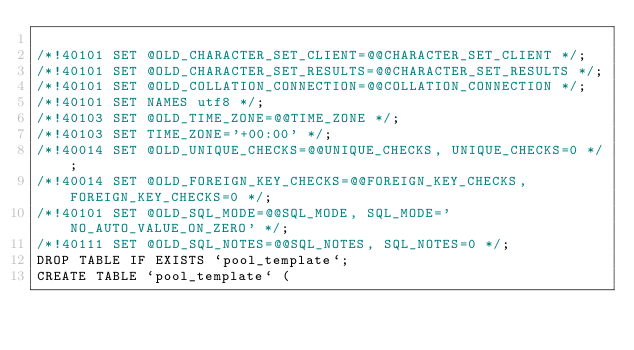<code> <loc_0><loc_0><loc_500><loc_500><_SQL_>
/*!40101 SET @OLD_CHARACTER_SET_CLIENT=@@CHARACTER_SET_CLIENT */;
/*!40101 SET @OLD_CHARACTER_SET_RESULTS=@@CHARACTER_SET_RESULTS */;
/*!40101 SET @OLD_COLLATION_CONNECTION=@@COLLATION_CONNECTION */;
/*!40101 SET NAMES utf8 */;
/*!40103 SET @OLD_TIME_ZONE=@@TIME_ZONE */;
/*!40103 SET TIME_ZONE='+00:00' */;
/*!40014 SET @OLD_UNIQUE_CHECKS=@@UNIQUE_CHECKS, UNIQUE_CHECKS=0 */;
/*!40014 SET @OLD_FOREIGN_KEY_CHECKS=@@FOREIGN_KEY_CHECKS, FOREIGN_KEY_CHECKS=0 */;
/*!40101 SET @OLD_SQL_MODE=@@SQL_MODE, SQL_MODE='NO_AUTO_VALUE_ON_ZERO' */;
/*!40111 SET @OLD_SQL_NOTES=@@SQL_NOTES, SQL_NOTES=0 */;
DROP TABLE IF EXISTS `pool_template`;
CREATE TABLE `pool_template` (</code> 